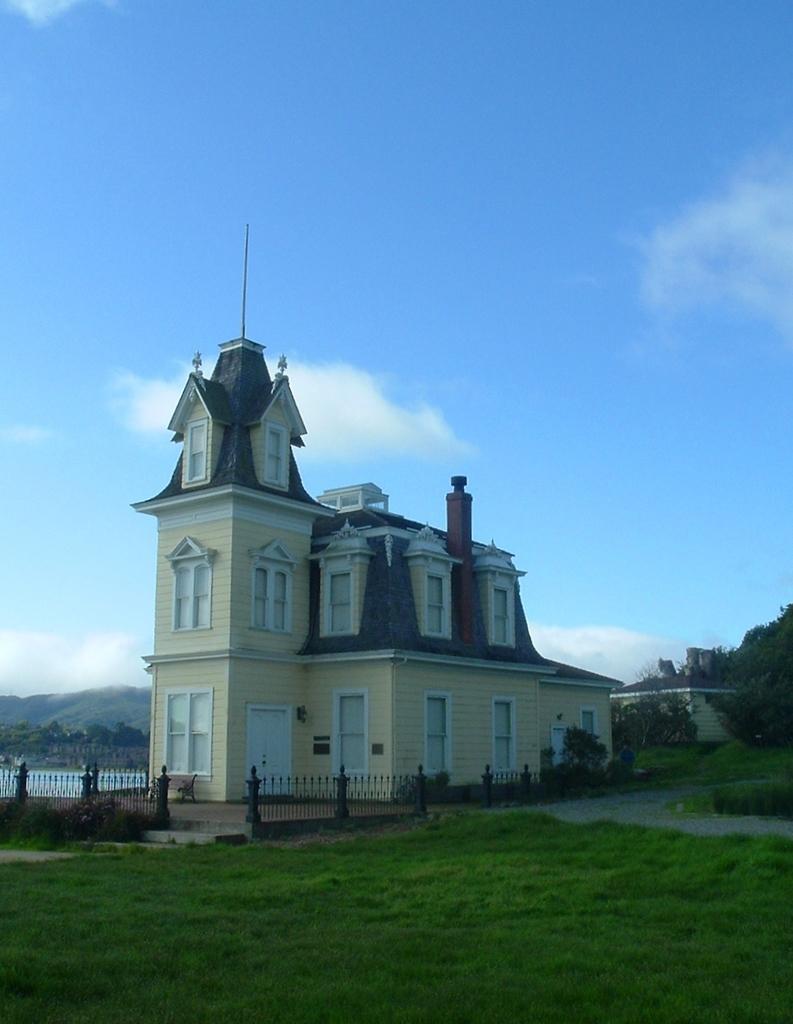Can you describe this image briefly? In this picture there is a building in the center of the image and there is grassland at the bottom side of the image, there are trees on the right and left side of the image. 